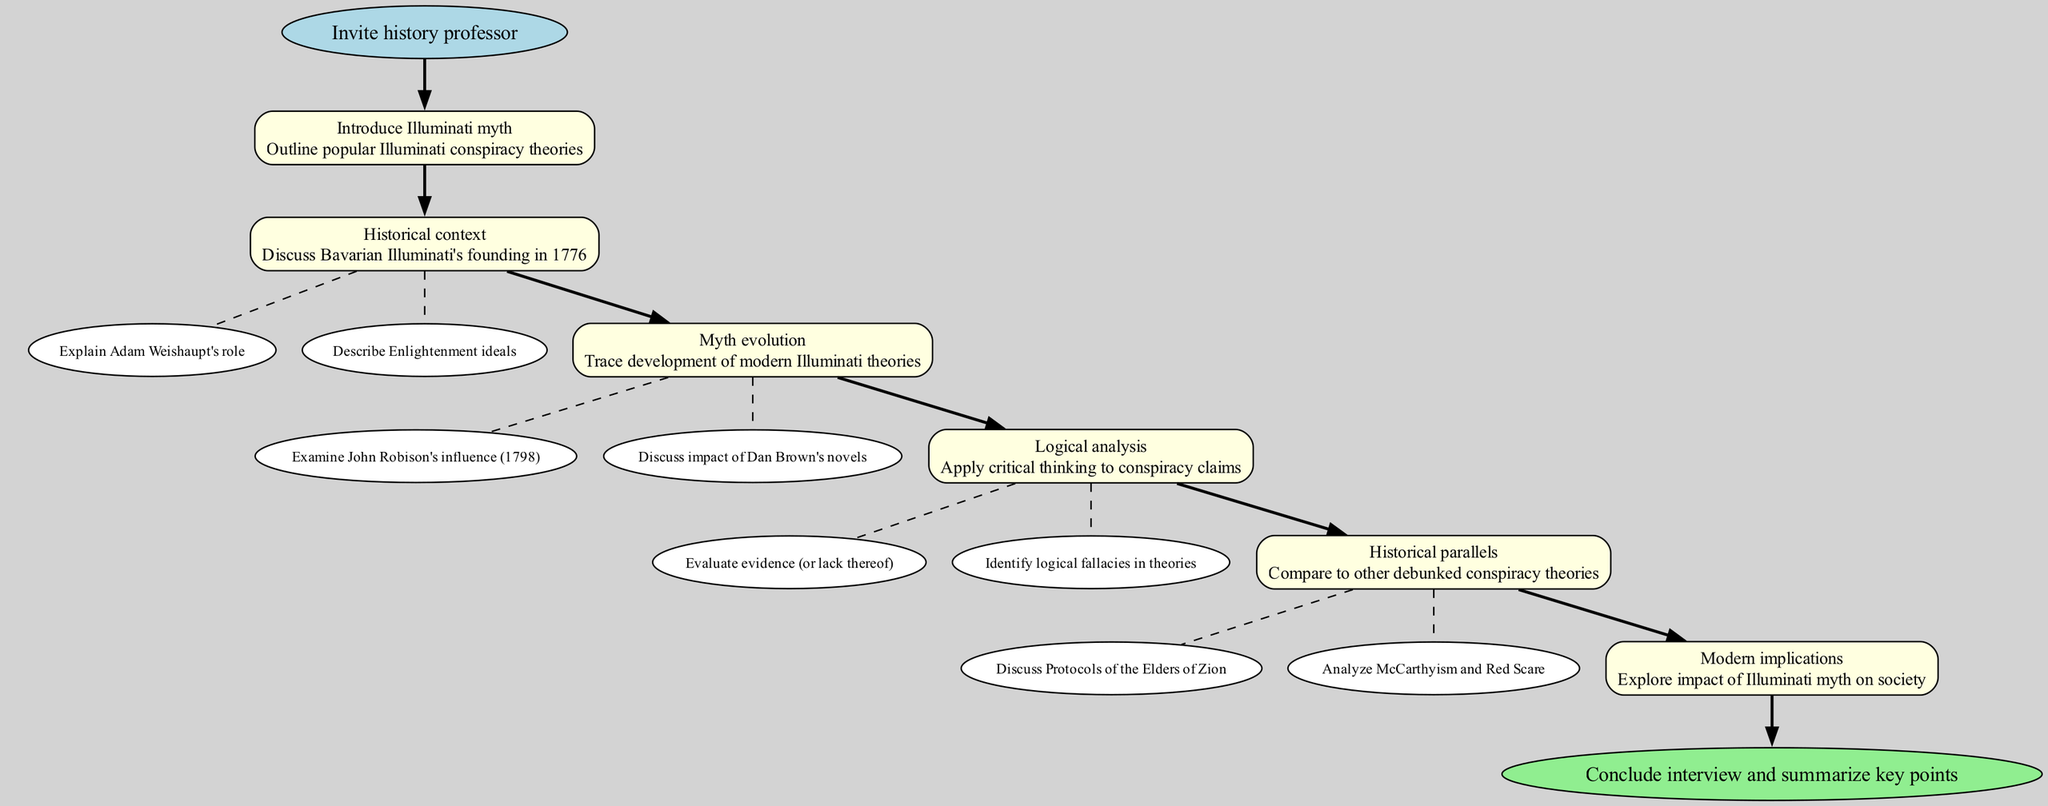What is the starting point of the clinical pathway? The diagram indicates that the starting point is labeled as "Invite history professor." This is the first node in the diagram and initiates the flow of the pathway.
Answer: Invite history professor How many steps are there in the clinical pathway? The diagram outlines a total of six steps each labeled distinctly. Following the start, there are five subsequent steps leading to the conclusion.
Answer: 6 What is the name of the final step in the clinical pathway? The last node, which concludes the flow of the pathway, is labeled "Conclude interview and summarize key points." This signifies the ending point of the discussion.
Answer: Conclude interview and summarize key points Which step discusses the founding of the Bavarian Illuminati? The step titled "Historical context" contains the relevant information about the founding of the Bavarian Illuminati in 1776, making this step pivotal in providing historical background.
Answer: Historical context What are the substeps associated with the "Myth evolution" step? The "Myth evolution" step includes two substeps: "Examine John Robison's influence (1798)" and "Discuss impact of Dan Brown's novels." These details indicate the specific areas explored within that step.
Answer: Examine John Robison's influence (1798) and Discuss impact of Dan Brown's novels Which node follows the "Introduce Illuminati myth" step directly? The diagram shows that the step labeled "Historical context" directly follows the "Introduce Illuminati myth" step. This indicates a progression in the discussion topics from introduction to historical analysis.
Answer: Historical context What kind of analysis is applied in the "Logical analysis" step? In the "Logical analysis" step, critical thinking applies to conspiracy claims, focusing specifically on evaluating evidence and identifying logical fallacies. This step is crucial for deconstructing conspiracy theories.
Answer: Critical thinking How does the clinical pathway compare the Illuminati myth with other theories? The step titled "Historical parallels" is where the Illuminati myth is compared to other debunked conspiracy theories, such as the "Protocols of the Elders of Zion" and "McCarthyism and Red Scare." This suggests a broader analytical framework.
Answer: Historical parallels 